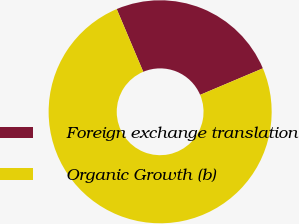Convert chart. <chart><loc_0><loc_0><loc_500><loc_500><pie_chart><fcel>Foreign exchange translation<fcel>Organic Growth (b)<nl><fcel>25.0%<fcel>75.0%<nl></chart> 